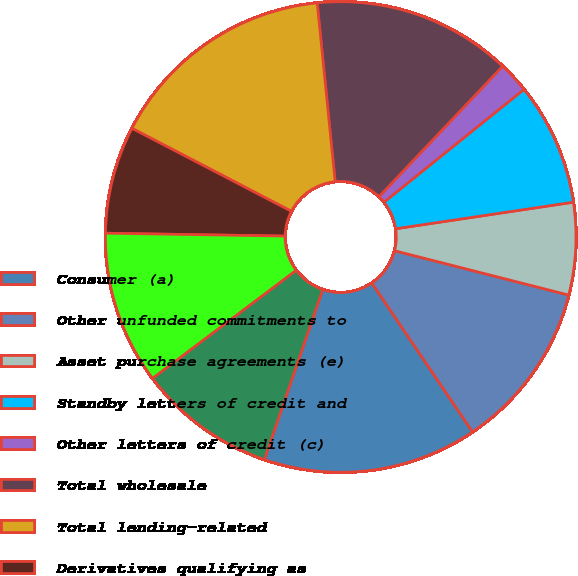Convert chart. <chart><loc_0><loc_0><loc_500><loc_500><pie_chart><fcel>Consumer (a)<fcel>Other unfunded commitments to<fcel>Asset purchase agreements (e)<fcel>Standby letters of credit and<fcel>Other letters of credit (c)<fcel>Total wholesale<fcel>Total lending-related<fcel>Derivatives qualifying as<fcel>Time deposits<fcel>Long-term debt<nl><fcel>14.72%<fcel>11.57%<fcel>6.33%<fcel>8.43%<fcel>2.13%<fcel>13.67%<fcel>15.77%<fcel>7.38%<fcel>10.52%<fcel>9.48%<nl></chart> 